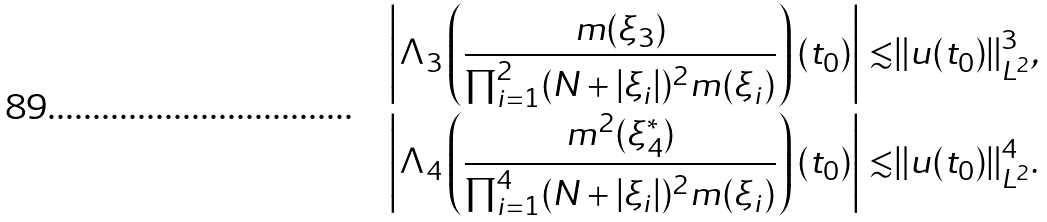Convert formula to latex. <formula><loc_0><loc_0><loc_500><loc_500>\left | \Lambda _ { 3 } \left ( \frac { m ( \xi _ { 3 } ) } { \prod _ { i = 1 } ^ { 2 } ( N + | \xi _ { i } | ) ^ { 2 } m ( \xi _ { i } ) } \right ) ( t _ { 0 } ) \right | \lesssim & \| u ( t _ { 0 } ) \| _ { L ^ { 2 } } ^ { 3 } , \\ \left | \Lambda _ { 4 } \left ( \frac { m ^ { 2 } ( \xi _ { 4 } ^ { * } ) } { \prod _ { i = 1 } ^ { 4 } ( N + | \xi _ { i } | ) ^ { 2 } m ( \xi _ { i } ) } \right ) ( t _ { 0 } ) \right | \lesssim & \| u ( t _ { 0 } ) \| _ { L ^ { 2 } } ^ { 4 } .</formula> 